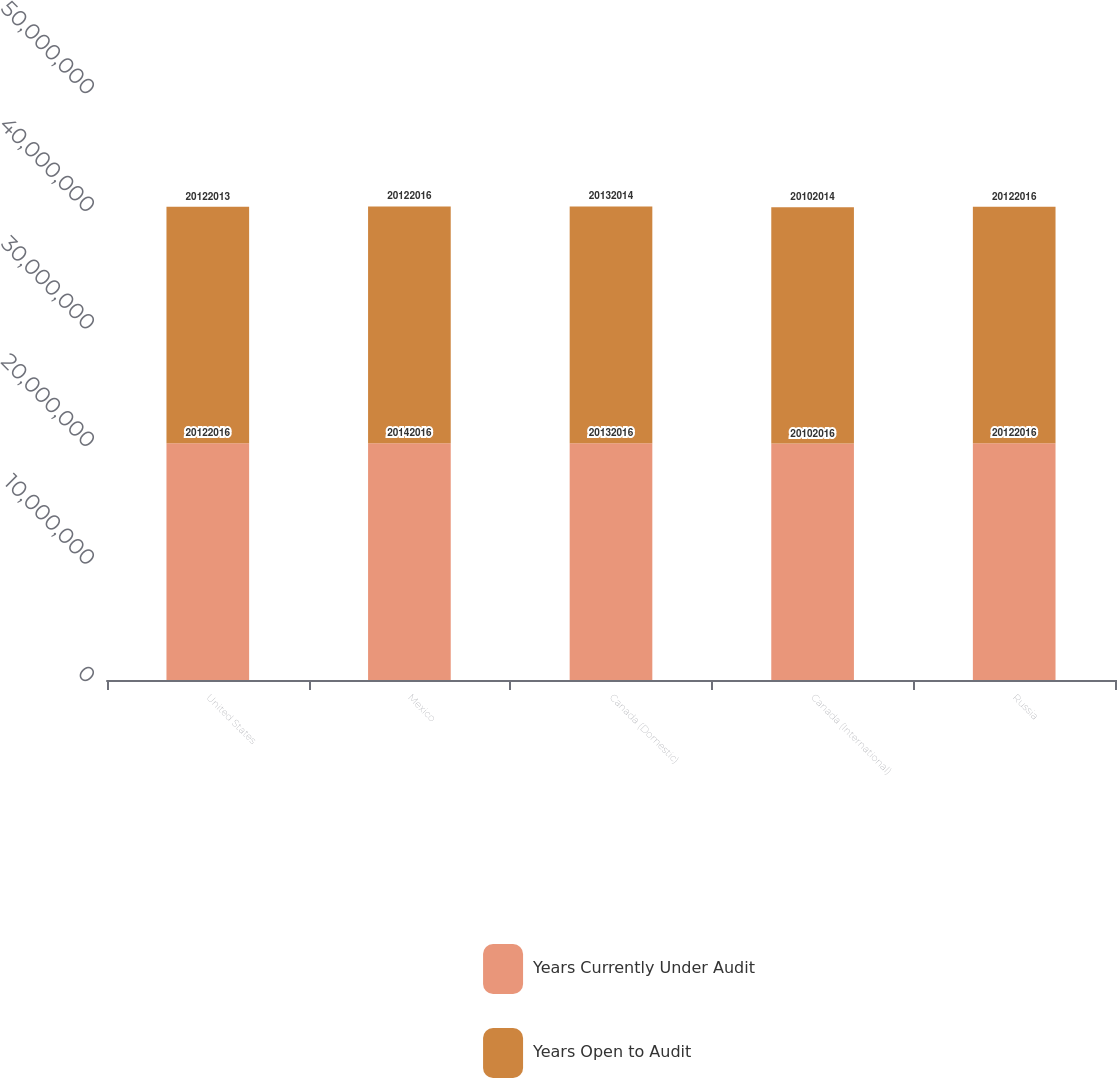Convert chart to OTSL. <chart><loc_0><loc_0><loc_500><loc_500><stacked_bar_chart><ecel><fcel>United States<fcel>Mexico<fcel>Canada (Domestic)<fcel>Canada (International)<fcel>Russia<nl><fcel>Years Currently Under Audit<fcel>2.0122e+07<fcel>2.0142e+07<fcel>2.0132e+07<fcel>2.0102e+07<fcel>2.0122e+07<nl><fcel>Years Open to Audit<fcel>2.0122e+07<fcel>2.0122e+07<fcel>2.0132e+07<fcel>2.0102e+07<fcel>2.0122e+07<nl></chart> 